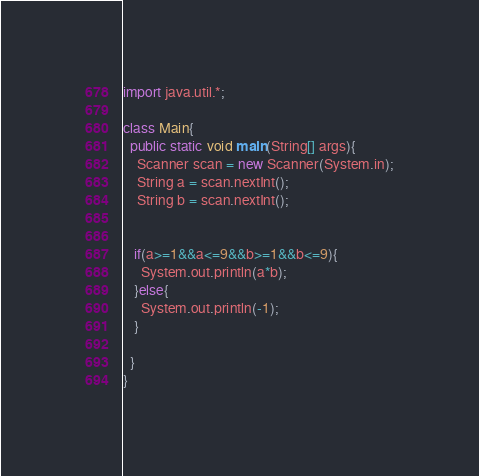<code> <loc_0><loc_0><loc_500><loc_500><_Java_>import java.util.*;

class Main{
  public static void main(String[] args){
    Scanner scan = new Scanner(System.in);
    String a = scan.nextInt();
    String b = scan.nextInt();
    
    
   if(a>=1&&a<=9&&b>=1&&b<=9){
     System.out.println(a*b);
   }else{
     System.out.println(-1);
   }
     
  }
}
</code> 